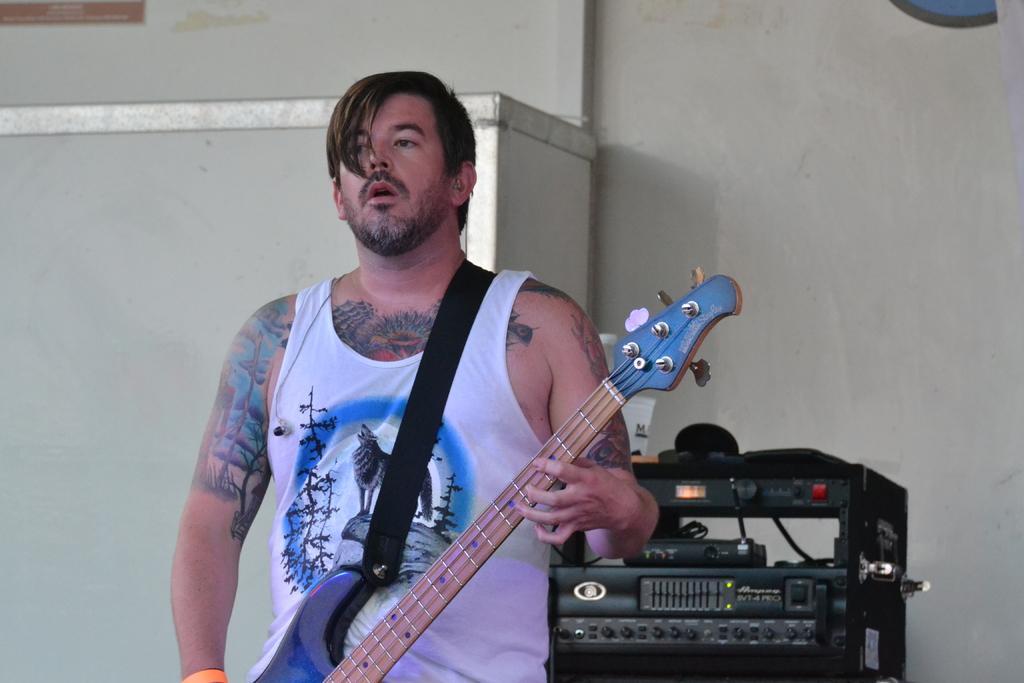Could you give a brief overview of what you see in this image? In this image the man is standing and holding a guitar. He has a tattoo on his hand. At the back side i can see a machine and a white wall. 